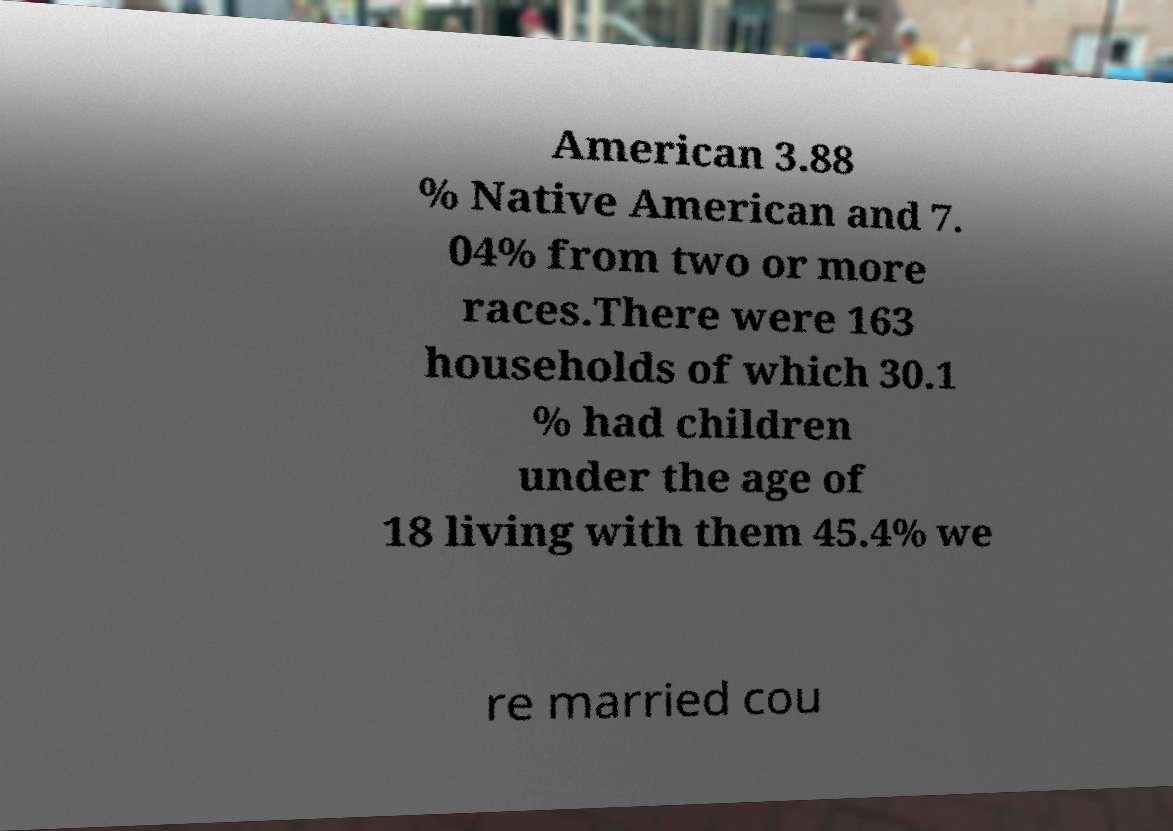There's text embedded in this image that I need extracted. Can you transcribe it verbatim? American 3.88 % Native American and 7. 04% from two or more races.There were 163 households of which 30.1 % had children under the age of 18 living with them 45.4% we re married cou 